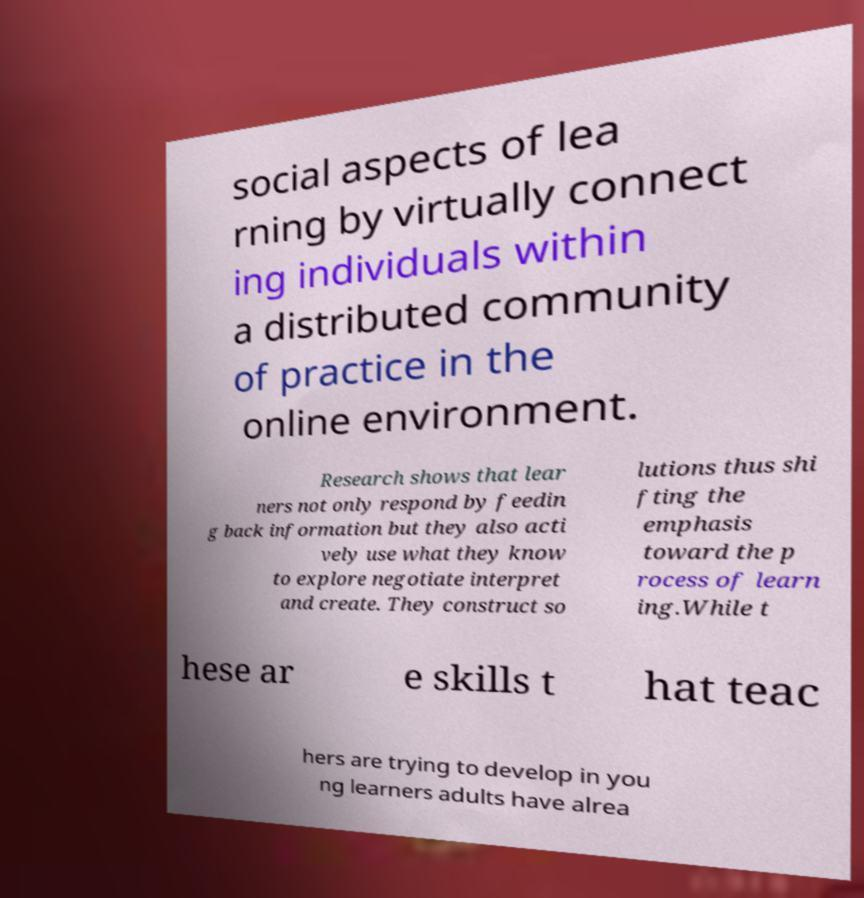Could you extract and type out the text from this image? social aspects of lea rning by virtually connect ing individuals within a distributed community of practice in the online environment. Research shows that lear ners not only respond by feedin g back information but they also acti vely use what they know to explore negotiate interpret and create. They construct so lutions thus shi fting the emphasis toward the p rocess of learn ing.While t hese ar e skills t hat teac hers are trying to develop in you ng learners adults have alrea 